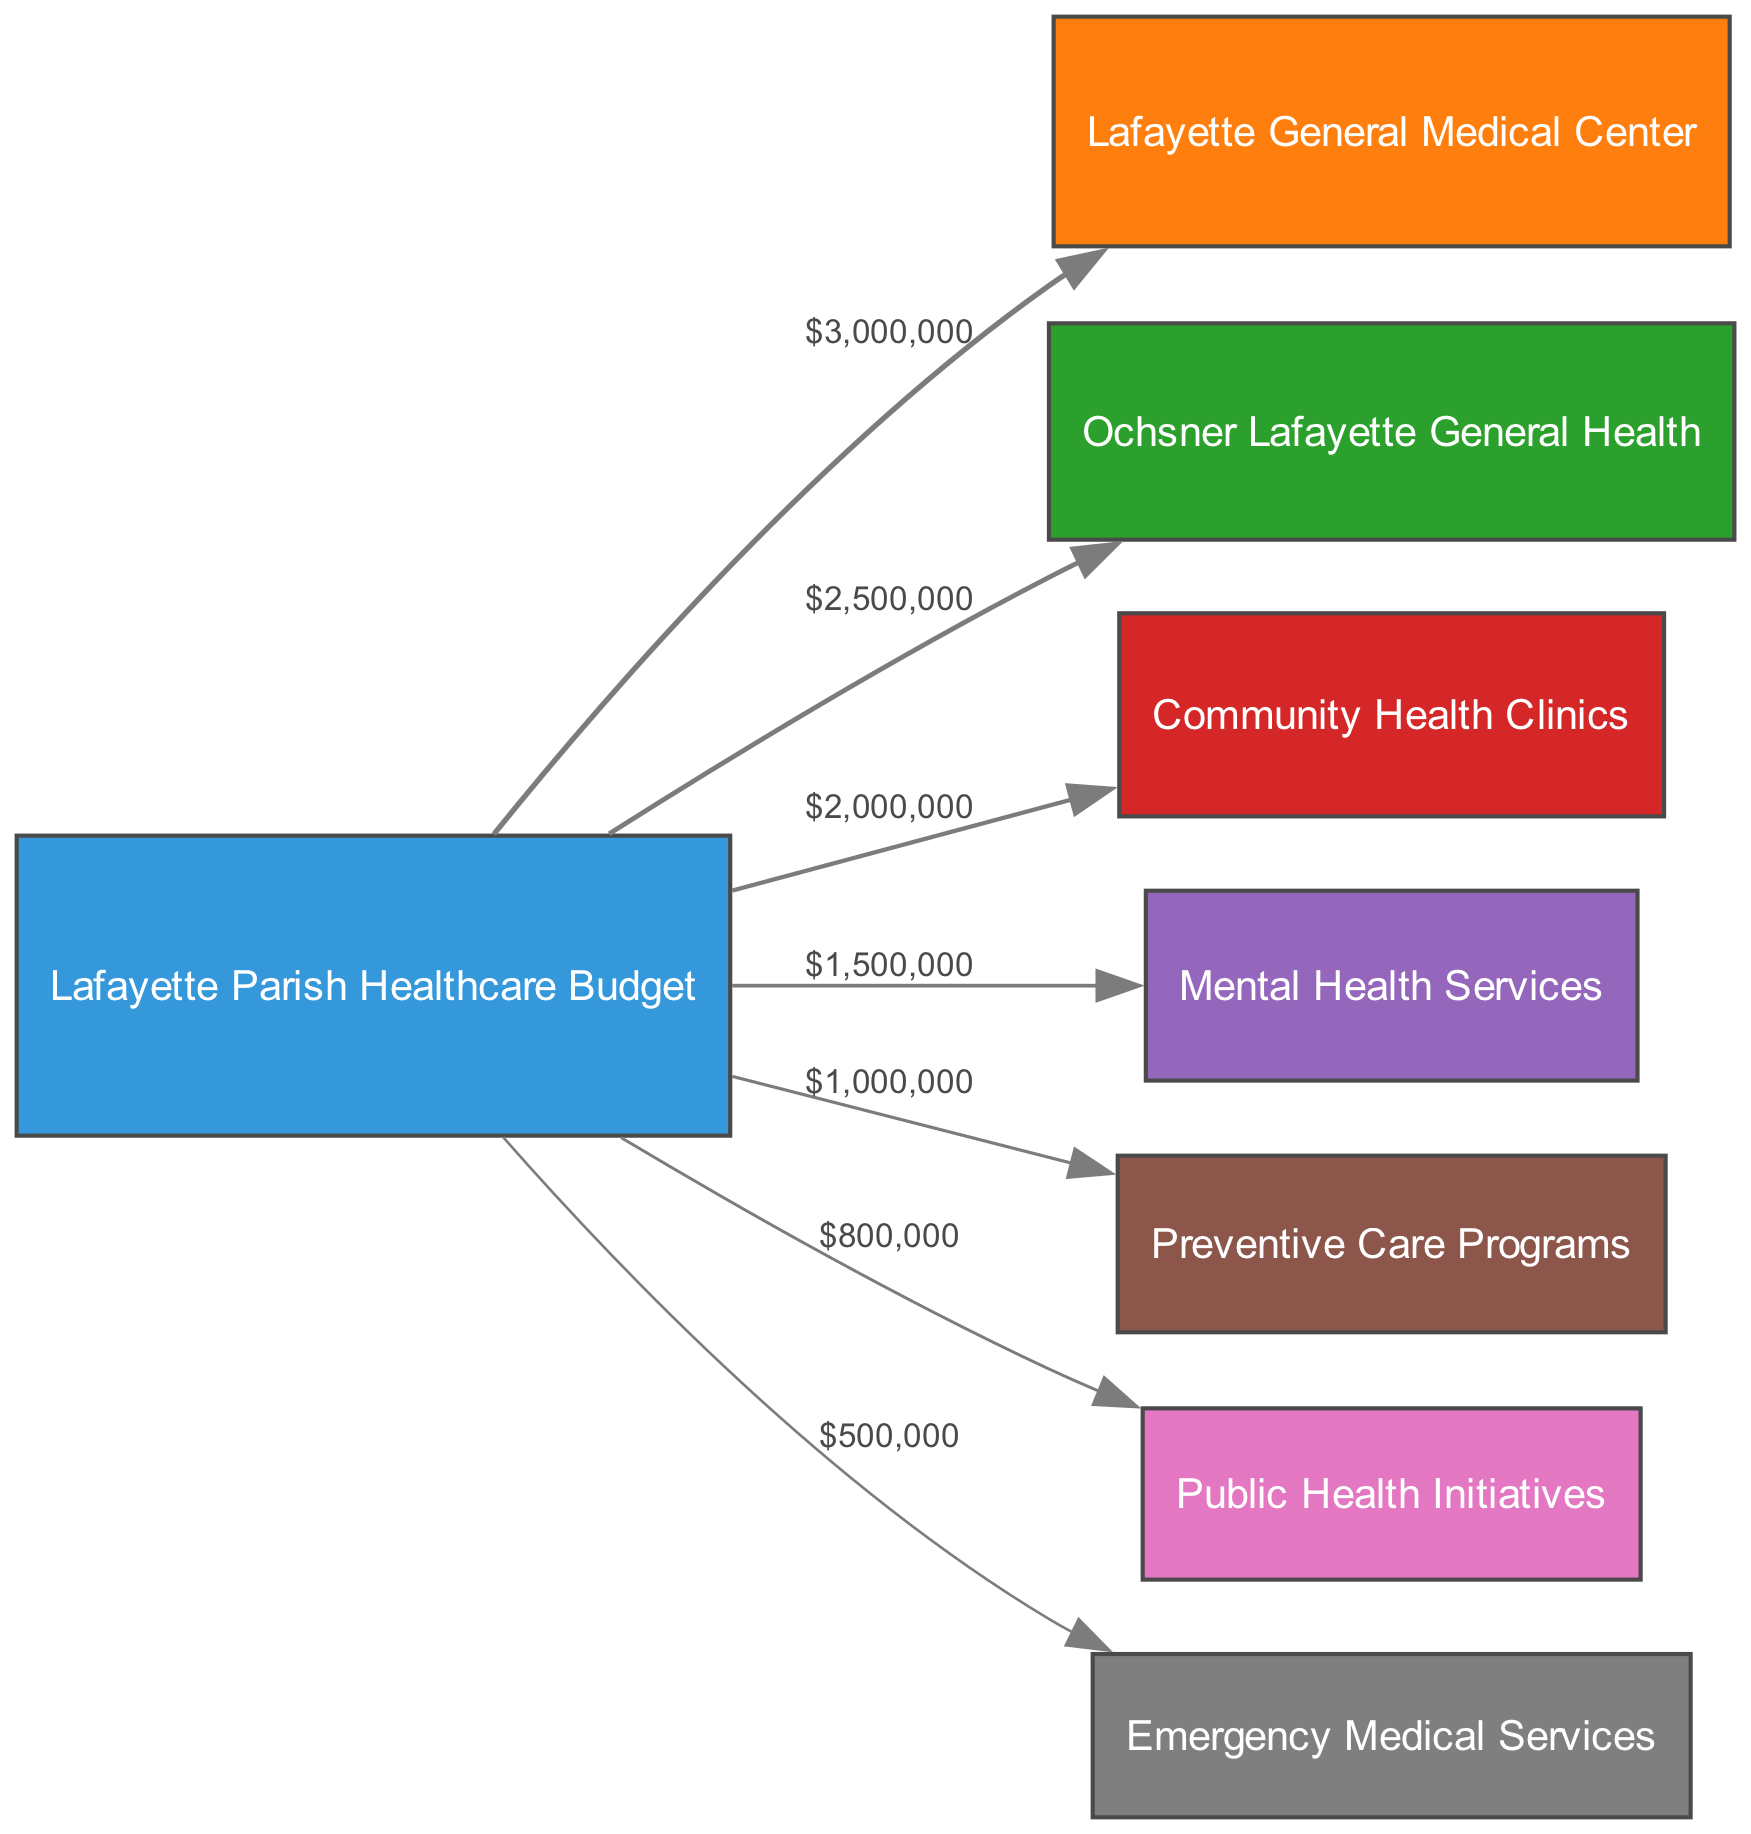What is the total funding allocated to Lafayette General Medical Center? The diagram shows a direct flow from the Lafayette Parish Healthcare Budget to Lafayette General Medical Center with a value labeled as $3,000,000.
Answer: $3,000,000 How much funding flows to Community Health Clinics? The link from the Lafayette Parish Healthcare Budget to Community Health Clinics indicates a funding flow of $2,000,000.
Answer: $2,000,000 Which health service receives the least funding? By comparing the values of all links, the one that has the smallest value is directed towards Emergency Medical Services, which has a funding flow of $500,000.
Answer: Emergency Medical Services How many health services are funded by the Lafayette Parish Healthcare Budget? There are a total of seven destination nodes in the diagram representing different health services, indicating that seven services receive funding.
Answer: 7 What is the total healthcare budget for Lafayette Parish? To find the total budget, add all the values of the links: $3,000,000 + $2,500,000 + $2,000,000 + $1,500,000 + $1,000,000 + $800,000 + $500,000, which equals $11,300,000.
Answer: $11,300,000 Which service receives the highest funding after Lafayette General Medical Center? The next highest flow after Lafayette General Medical Center is directed to Ochsner Lafayette General Health, which shows a funding of $2,500,000.
Answer: Ochsner Lafayette General Health Is there a flow directing funding to Preventive Care Programs? Yes, there is a link from the Lafayette Parish Healthcare Budget pointing towards Preventive Care Programs with a value of $1,000,000.
Answer: Yes Which two health services combined receive more than $4 million? By adding the values for Lafayette General Medical Center ($3,000,000) and Ochsner Lafayette General Health ($2,500,000), their combined total is $5,500,000, which exceeds $4 million.
Answer: Lafayette General Medical Center and Ochsner Lafayette General Health What is the flow value for Mental Health Services? The diagram includes a connection from the Lafayette Parish Healthcare Budget to Mental Health Services of $1,500,000.
Answer: $1,500,000 